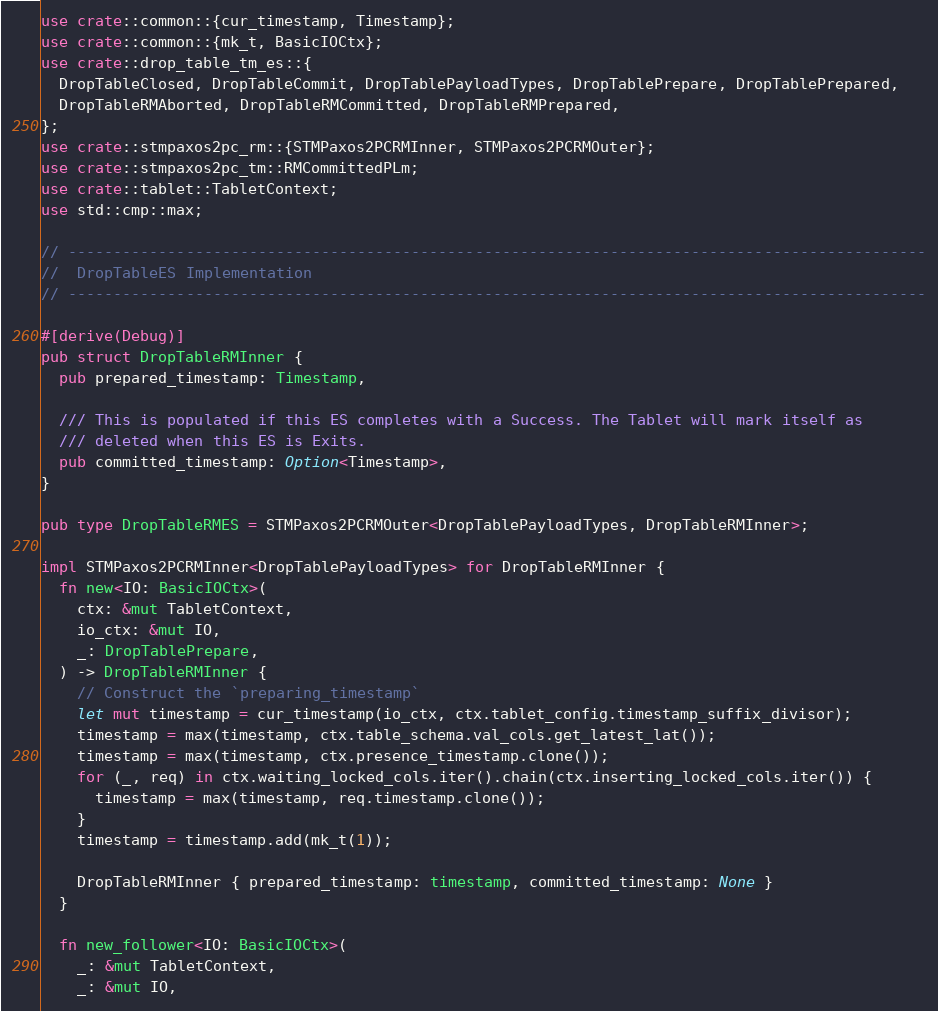Convert code to text. <code><loc_0><loc_0><loc_500><loc_500><_Rust_>use crate::common::{cur_timestamp, Timestamp};
use crate::common::{mk_t, BasicIOCtx};
use crate::drop_table_tm_es::{
  DropTableClosed, DropTableCommit, DropTablePayloadTypes, DropTablePrepare, DropTablePrepared,
  DropTableRMAborted, DropTableRMCommitted, DropTableRMPrepared,
};
use crate::stmpaxos2pc_rm::{STMPaxos2PCRMInner, STMPaxos2PCRMOuter};
use crate::stmpaxos2pc_tm::RMCommittedPLm;
use crate::tablet::TabletContext;
use std::cmp::max;

// -----------------------------------------------------------------------------------------------
//  DropTableES Implementation
// -----------------------------------------------------------------------------------------------

#[derive(Debug)]
pub struct DropTableRMInner {
  pub prepared_timestamp: Timestamp,

  /// This is populated if this ES completes with a Success. The Tablet will mark itself as
  /// deleted when this ES is Exits.
  pub committed_timestamp: Option<Timestamp>,
}

pub type DropTableRMES = STMPaxos2PCRMOuter<DropTablePayloadTypes, DropTableRMInner>;

impl STMPaxos2PCRMInner<DropTablePayloadTypes> for DropTableRMInner {
  fn new<IO: BasicIOCtx>(
    ctx: &mut TabletContext,
    io_ctx: &mut IO,
    _: DropTablePrepare,
  ) -> DropTableRMInner {
    // Construct the `preparing_timestamp`
    let mut timestamp = cur_timestamp(io_ctx, ctx.tablet_config.timestamp_suffix_divisor);
    timestamp = max(timestamp, ctx.table_schema.val_cols.get_latest_lat());
    timestamp = max(timestamp, ctx.presence_timestamp.clone());
    for (_, req) in ctx.waiting_locked_cols.iter().chain(ctx.inserting_locked_cols.iter()) {
      timestamp = max(timestamp, req.timestamp.clone());
    }
    timestamp = timestamp.add(mk_t(1));

    DropTableRMInner { prepared_timestamp: timestamp, committed_timestamp: None }
  }

  fn new_follower<IO: BasicIOCtx>(
    _: &mut TabletContext,
    _: &mut IO,</code> 